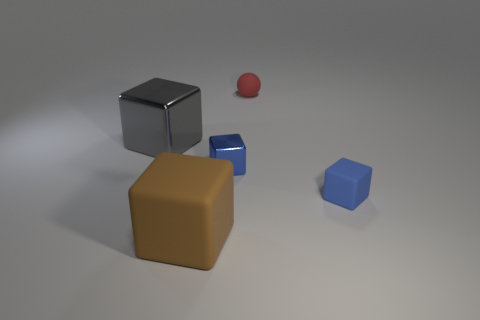What size is the blue block on the right side of the red matte sphere that is right of the shiny cube on the left side of the brown object?
Give a very brief answer. Small. How many brown things are large metal cubes or small objects?
Give a very brief answer. 0. Do the brown rubber object in front of the blue metallic thing and the gray metal object have the same shape?
Keep it short and to the point. Yes. Is the number of tiny blue rubber blocks that are to the right of the small blue matte cube greater than the number of blue metal things?
Your answer should be very brief. No. How many purple balls are the same size as the red rubber object?
Offer a very short reply. 0. What size is the rubber object that is the same color as the tiny metallic object?
Offer a very short reply. Small. How many objects are gray cubes or matte objects that are to the right of the brown object?
Offer a very short reply. 3. What is the color of the block that is both in front of the gray metallic cube and behind the small blue rubber block?
Your answer should be compact. Blue. Do the red rubber thing and the blue matte object have the same size?
Your response must be concise. Yes. What is the color of the tiny rubber object that is in front of the tiny shiny thing?
Offer a very short reply. Blue. 